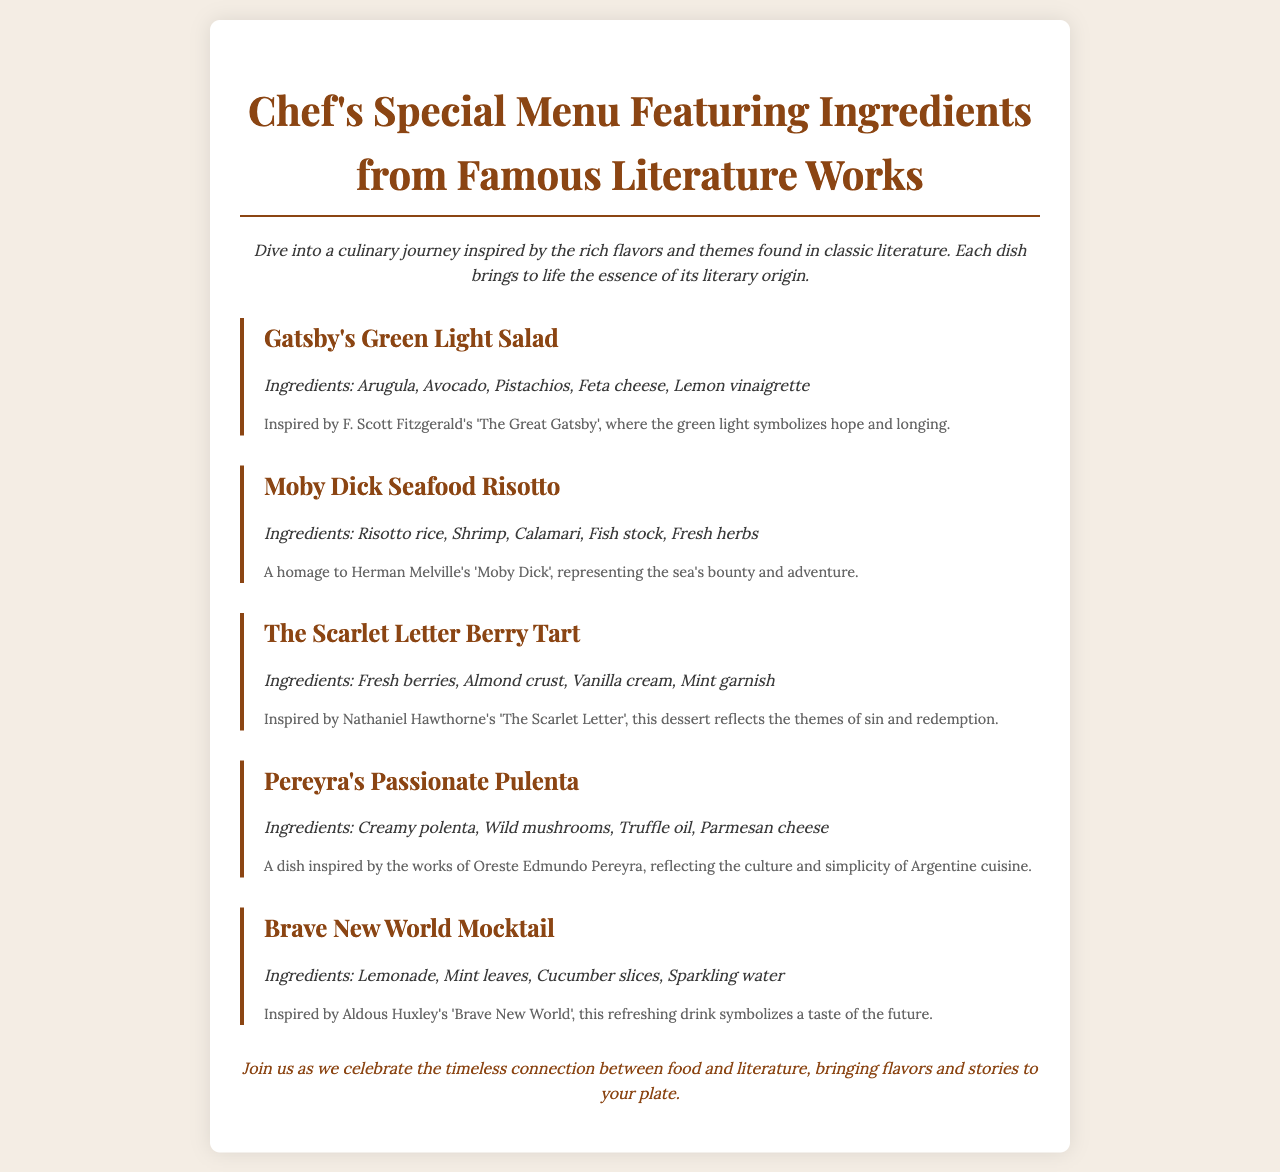What is the title of the menu? The title of the menu is prominently displayed at the top of the document, indicating its theme related to literature.
Answer: Chef's Special Menu Featuring Ingredients from Famous Literature Works Which dish includes shrimp? The dish that includes shrimp can be found in the ingredients section of the menu items, specifically within the seafood risotto.
Answer: Moby Dick Seafood Risotto What ingredient is used in Gatsby's Green Light Salad? The document lists specific ingredients for each dish, and one ingredient for Gatsby's salad is mentioned clearly.
Answer: Arugula Who inspired the dish 'Pereyra's Passionate Pulenta'? Each dish is accompanied by a literary reference, providing the author behind the inspiration for that particular dish.
Answer: Oreste Edmundo Pereyra How many dishes are featured in the menu? The document lists out all the dishes in the menu, allowing for easy counting of each item presented.
Answer: Five 